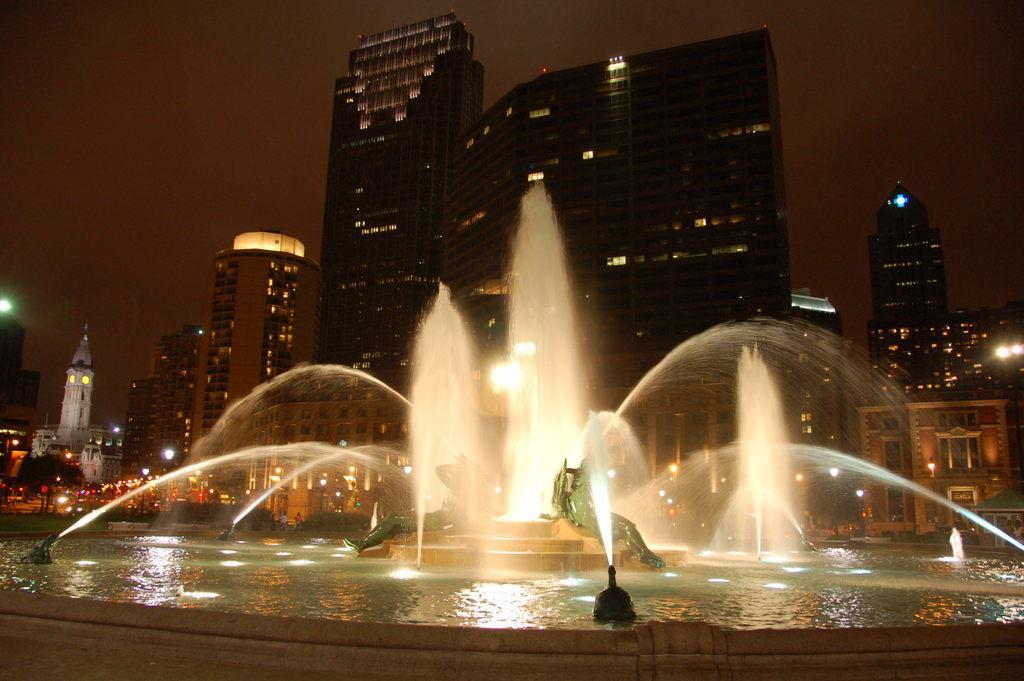What structures can be seen in the image? There are buildings in the image. What is located in front of the buildings? There is a fountain in front of the buildings. What is at the center of the fountain? At the center of the fountain, there are statues. What can be seen in the background of the image? The sky is visible in the background of the image. How does the son contribute to the maintenance of the buildings in the image? There is no mention of a son in the image, and therefore no information about his contribution to the maintenance of the buildings. 